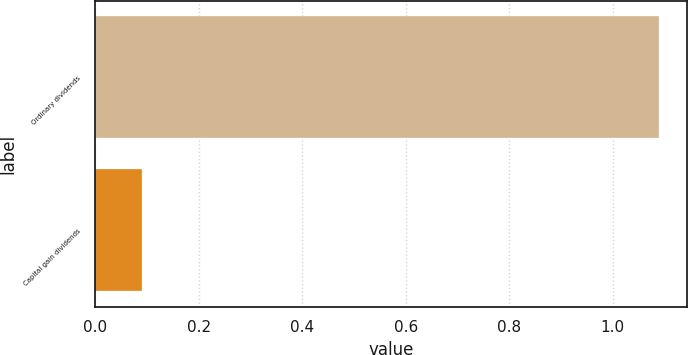<chart> <loc_0><loc_0><loc_500><loc_500><bar_chart><fcel>Ordinary dividends<fcel>Capital gain dividends<nl><fcel>1.09<fcel>0.09<nl></chart> 